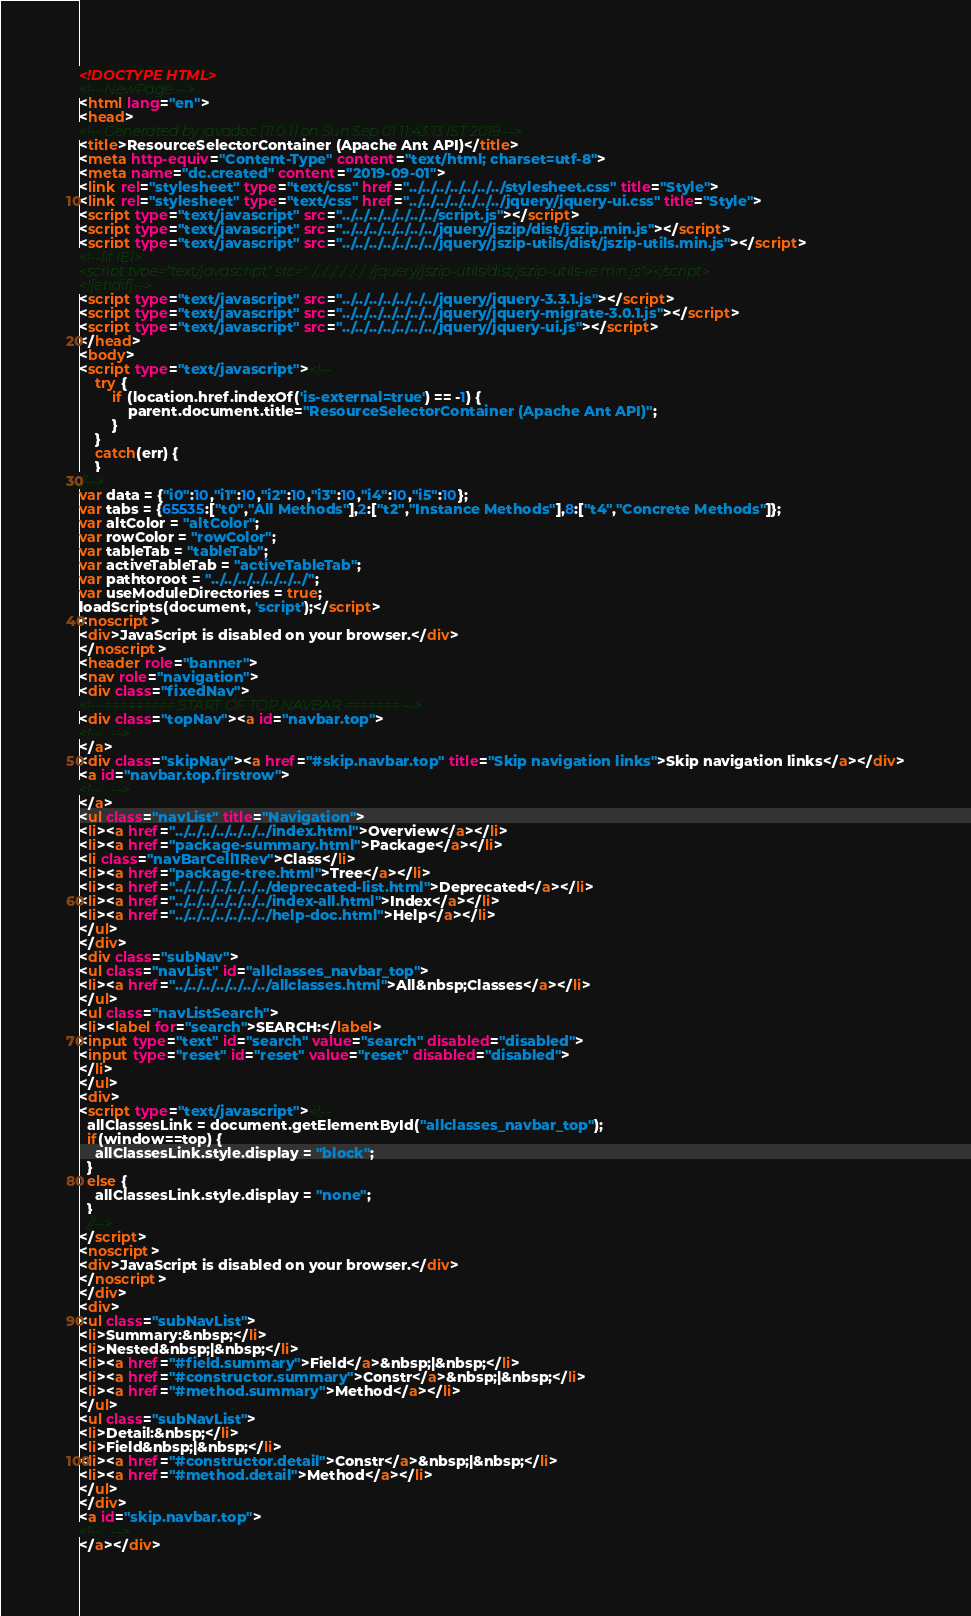Convert code to text. <code><loc_0><loc_0><loc_500><loc_500><_HTML_><!DOCTYPE HTML>
<!-- NewPage -->
<html lang="en">
<head>
<!-- Generated by javadoc (11.0.1) on Sun Sep 01 11:43:13 IST 2019 -->
<title>ResourceSelectorContainer (Apache Ant API)</title>
<meta http-equiv="Content-Type" content="text/html; charset=utf-8">
<meta name="dc.created" content="2019-09-01">
<link rel="stylesheet" type="text/css" href="../../../../../../../stylesheet.css" title="Style">
<link rel="stylesheet" type="text/css" href="../../../../../../../jquery/jquery-ui.css" title="Style">
<script type="text/javascript" src="../../../../../../../script.js"></script>
<script type="text/javascript" src="../../../../../../../jquery/jszip/dist/jszip.min.js"></script>
<script type="text/javascript" src="../../../../../../../jquery/jszip-utils/dist/jszip-utils.min.js"></script>
<!--[if IE]>
<script type="text/javascript" src="../../../../../../../jquery/jszip-utils/dist/jszip-utils-ie.min.js"></script>
<![endif]-->
<script type="text/javascript" src="../../../../../../../jquery/jquery-3.3.1.js"></script>
<script type="text/javascript" src="../../../../../../../jquery/jquery-migrate-3.0.1.js"></script>
<script type="text/javascript" src="../../../../../../../jquery/jquery-ui.js"></script>
</head>
<body>
<script type="text/javascript"><!--
    try {
        if (location.href.indexOf('is-external=true') == -1) {
            parent.document.title="ResourceSelectorContainer (Apache Ant API)";
        }
    }
    catch(err) {
    }
//-->
var data = {"i0":10,"i1":10,"i2":10,"i3":10,"i4":10,"i5":10};
var tabs = {65535:["t0","All Methods"],2:["t2","Instance Methods"],8:["t4","Concrete Methods"]};
var altColor = "altColor";
var rowColor = "rowColor";
var tableTab = "tableTab";
var activeTableTab = "activeTableTab";
var pathtoroot = "../../../../../../../";
var useModuleDirectories = true;
loadScripts(document, 'script');</script>
<noscript>
<div>JavaScript is disabled on your browser.</div>
</noscript>
<header role="banner">
<nav role="navigation">
<div class="fixedNav">
<!-- ========= START OF TOP NAVBAR ======= -->
<div class="topNav"><a id="navbar.top">
<!--   -->
</a>
<div class="skipNav"><a href="#skip.navbar.top" title="Skip navigation links">Skip navigation links</a></div>
<a id="navbar.top.firstrow">
<!--   -->
</a>
<ul class="navList" title="Navigation">
<li><a href="../../../../../../../index.html">Overview</a></li>
<li><a href="package-summary.html">Package</a></li>
<li class="navBarCell1Rev">Class</li>
<li><a href="package-tree.html">Tree</a></li>
<li><a href="../../../../../../../deprecated-list.html">Deprecated</a></li>
<li><a href="../../../../../../../index-all.html">Index</a></li>
<li><a href="../../../../../../../help-doc.html">Help</a></li>
</ul>
</div>
<div class="subNav">
<ul class="navList" id="allclasses_navbar_top">
<li><a href="../../../../../../../allclasses.html">All&nbsp;Classes</a></li>
</ul>
<ul class="navListSearch">
<li><label for="search">SEARCH:</label>
<input type="text" id="search" value="search" disabled="disabled">
<input type="reset" id="reset" value="reset" disabled="disabled">
</li>
</ul>
<div>
<script type="text/javascript"><!--
  allClassesLink = document.getElementById("allclasses_navbar_top");
  if(window==top) {
    allClassesLink.style.display = "block";
  }
  else {
    allClassesLink.style.display = "none";
  }
  //-->
</script>
<noscript>
<div>JavaScript is disabled on your browser.</div>
</noscript>
</div>
<div>
<ul class="subNavList">
<li>Summary:&nbsp;</li>
<li>Nested&nbsp;|&nbsp;</li>
<li><a href="#field.summary">Field</a>&nbsp;|&nbsp;</li>
<li><a href="#constructor.summary">Constr</a>&nbsp;|&nbsp;</li>
<li><a href="#method.summary">Method</a></li>
</ul>
<ul class="subNavList">
<li>Detail:&nbsp;</li>
<li>Field&nbsp;|&nbsp;</li>
<li><a href="#constructor.detail">Constr</a>&nbsp;|&nbsp;</li>
<li><a href="#method.detail">Method</a></li>
</ul>
</div>
<a id="skip.navbar.top">
<!--   -->
</a></div></code> 